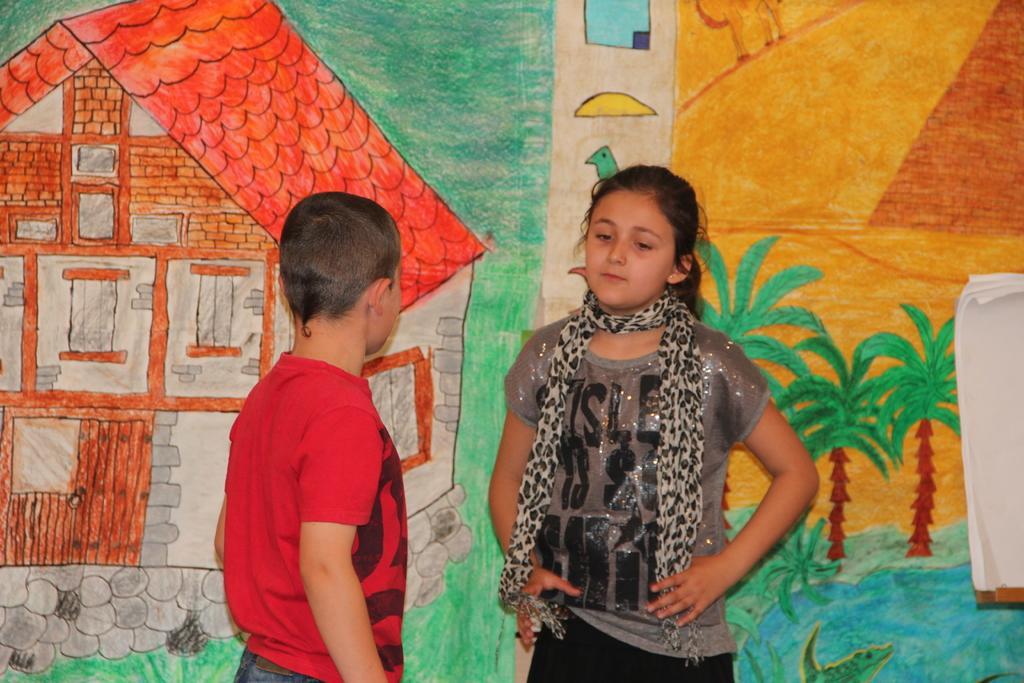Can you describe this image briefly? In this image there are two children standing, behind them there are few papers attached to the wall. On the wall there is a painting of huts, trees and birds. 